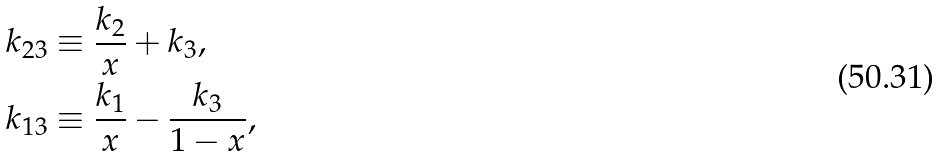Convert formula to latex. <formula><loc_0><loc_0><loc_500><loc_500>k _ { 2 3 } & \equiv \frac { k _ { 2 } } { x } + k _ { 3 } , \\ k _ { 1 3 } & \equiv \frac { k _ { 1 } } { x } - \frac { k _ { 3 } } { 1 - x } ,</formula> 